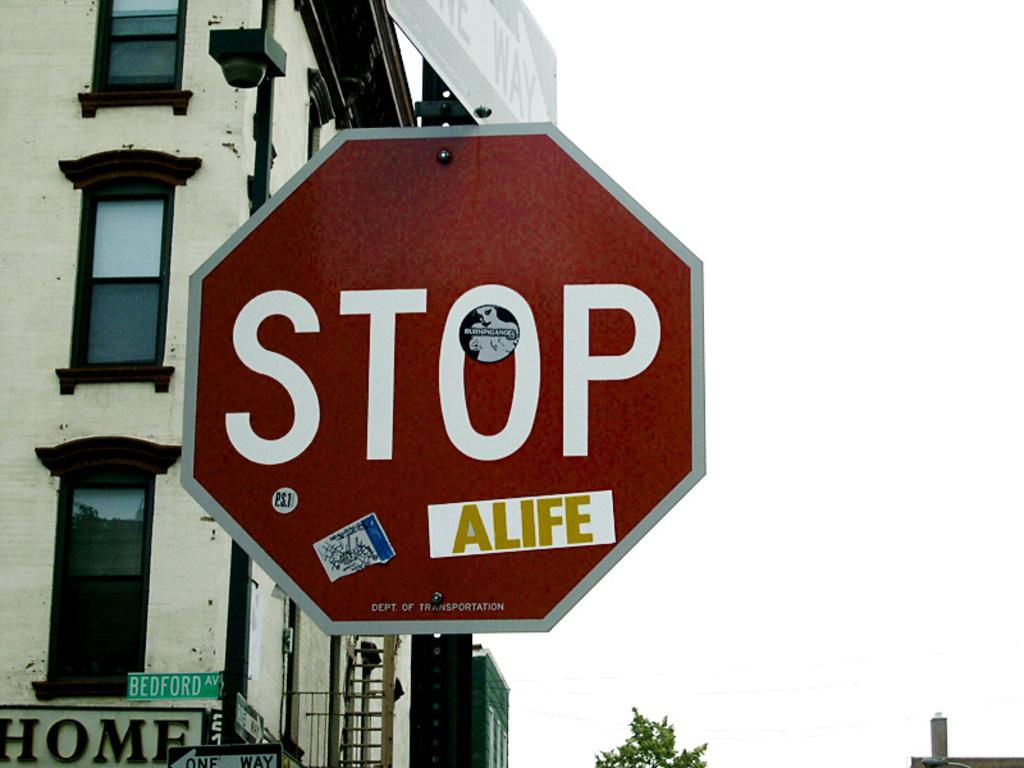<image>
Offer a succinct explanation of the picture presented. Street signs with a rectangular green side that has Bedford in white lettering. 